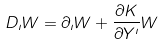<formula> <loc_0><loc_0><loc_500><loc_500>D _ { \imath } W = \partial _ { \imath } W + \frac { \partial K } { \partial Y ^ { \imath } } W</formula> 